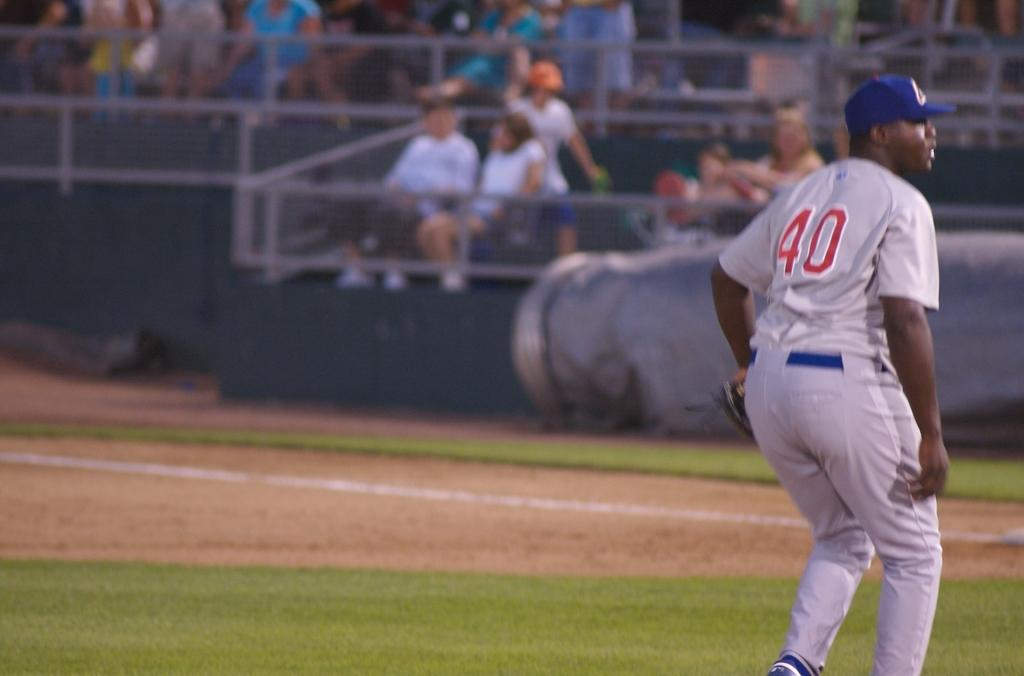<image>
Create a compact narrative representing the image presented. Baseball player wearing number 40 standing on the field. 